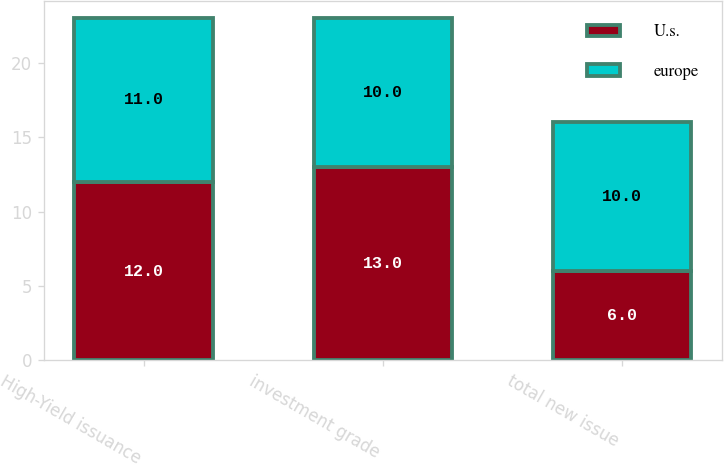Convert chart to OTSL. <chart><loc_0><loc_0><loc_500><loc_500><stacked_bar_chart><ecel><fcel>High-Yield issuance<fcel>investment grade<fcel>total new issue<nl><fcel>U.s.<fcel>12<fcel>13<fcel>6<nl><fcel>europe<fcel>11<fcel>10<fcel>10<nl></chart> 